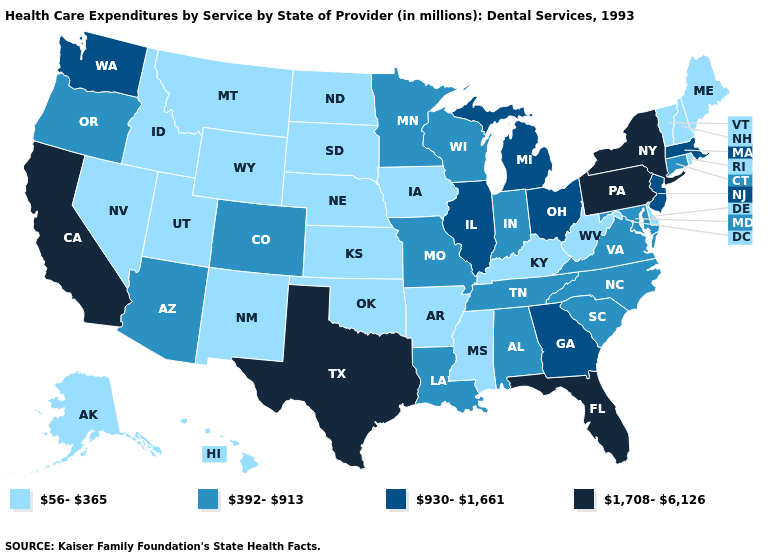What is the lowest value in states that border New Hampshire?
Give a very brief answer. 56-365. Does the first symbol in the legend represent the smallest category?
Short answer required. Yes. Name the states that have a value in the range 930-1,661?
Keep it brief. Georgia, Illinois, Massachusetts, Michigan, New Jersey, Ohio, Washington. Name the states that have a value in the range 56-365?
Answer briefly. Alaska, Arkansas, Delaware, Hawaii, Idaho, Iowa, Kansas, Kentucky, Maine, Mississippi, Montana, Nebraska, Nevada, New Hampshire, New Mexico, North Dakota, Oklahoma, Rhode Island, South Dakota, Utah, Vermont, West Virginia, Wyoming. Name the states that have a value in the range 1,708-6,126?
Short answer required. California, Florida, New York, Pennsylvania, Texas. What is the lowest value in the Northeast?
Answer briefly. 56-365. Does Oklahoma have the highest value in the South?
Give a very brief answer. No. What is the value of Delaware?
Concise answer only. 56-365. Name the states that have a value in the range 392-913?
Answer briefly. Alabama, Arizona, Colorado, Connecticut, Indiana, Louisiana, Maryland, Minnesota, Missouri, North Carolina, Oregon, South Carolina, Tennessee, Virginia, Wisconsin. What is the value of North Dakota?
Give a very brief answer. 56-365. What is the value of Colorado?
Concise answer only. 392-913. What is the highest value in the USA?
Answer briefly. 1,708-6,126. Does Wisconsin have the highest value in the USA?
Concise answer only. No. Does the first symbol in the legend represent the smallest category?
Concise answer only. Yes. Among the states that border North Carolina , does Tennessee have the highest value?
Answer briefly. No. 